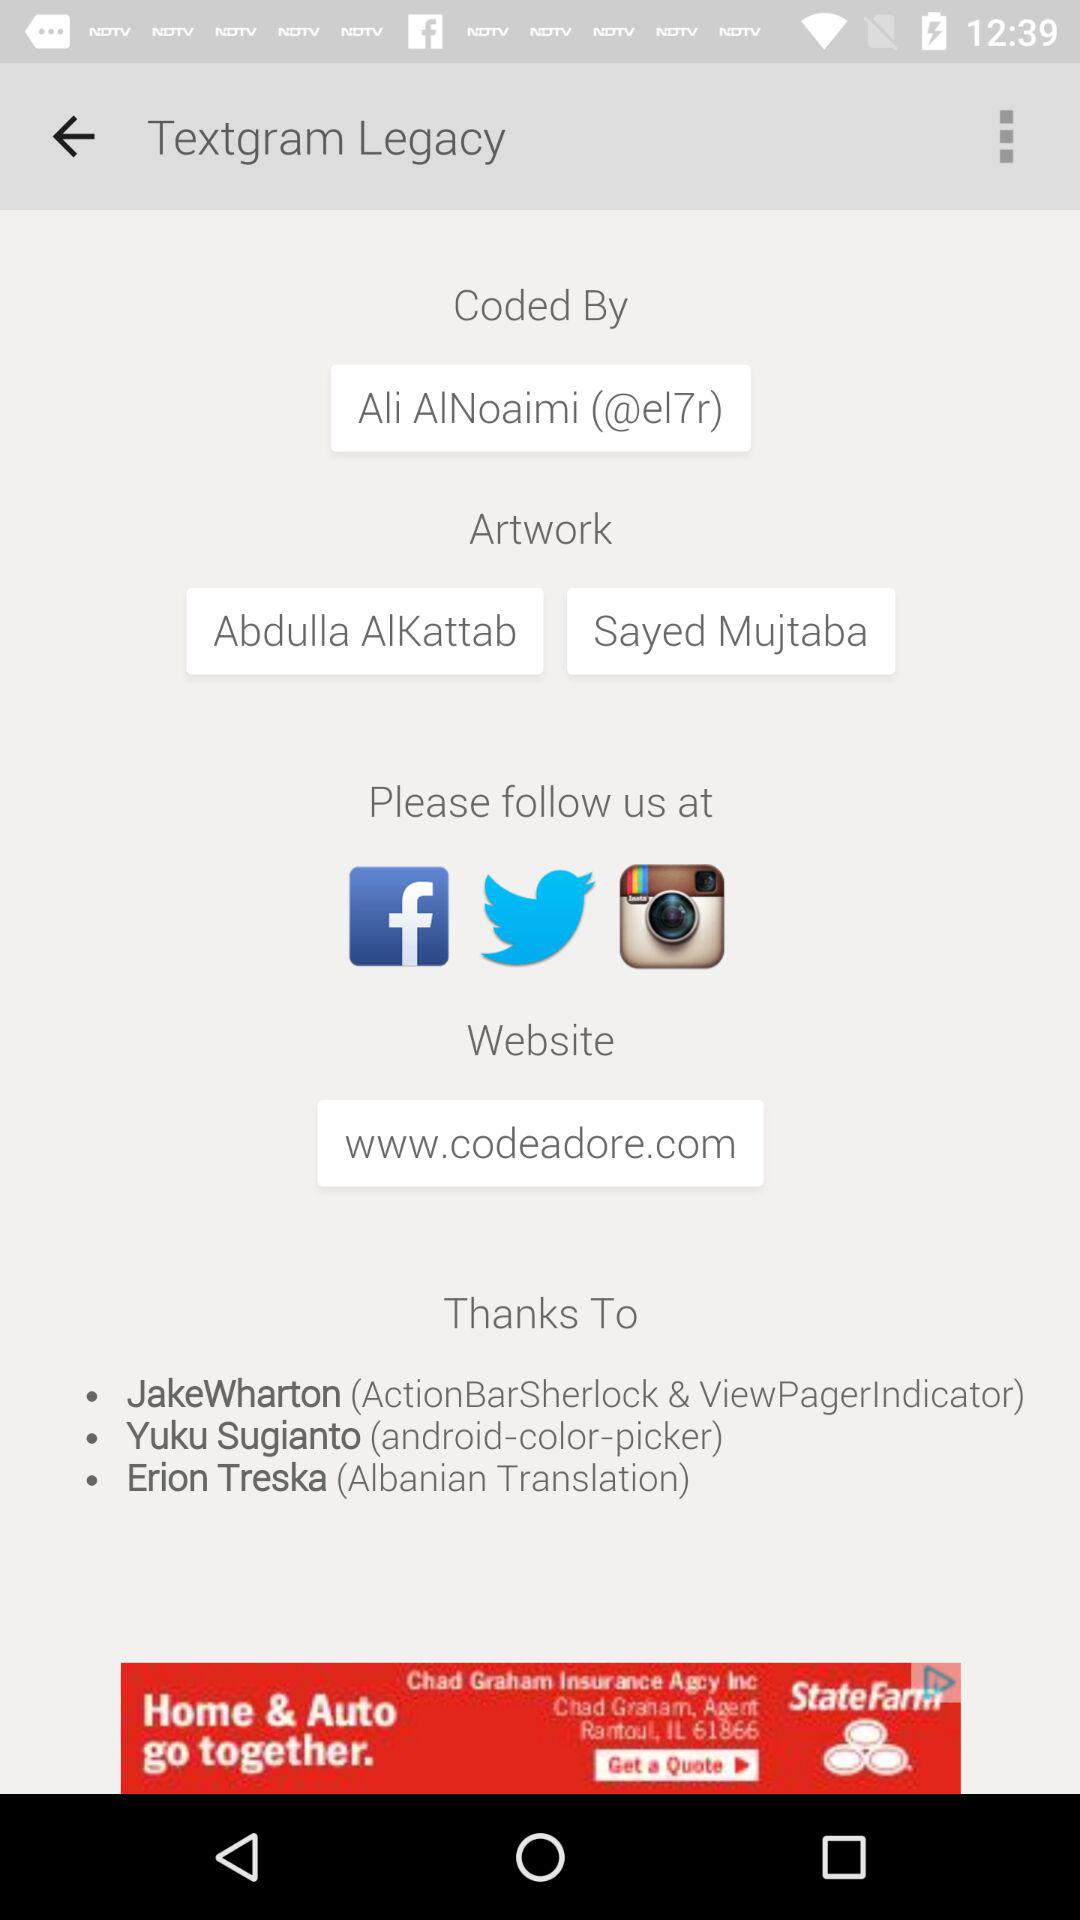How many more people are credited for artwork than website?
Answer the question using a single word or phrase. 1 